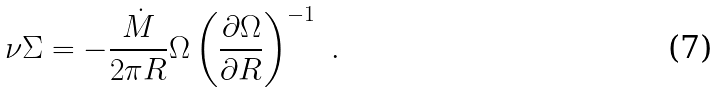Convert formula to latex. <formula><loc_0><loc_0><loc_500><loc_500>\nu \Sigma = - \frac { \dot { M } } { 2 \pi R } \Omega \left ( \frac { \partial \Omega } { \partial R } \right ) ^ { - 1 } \ .</formula> 